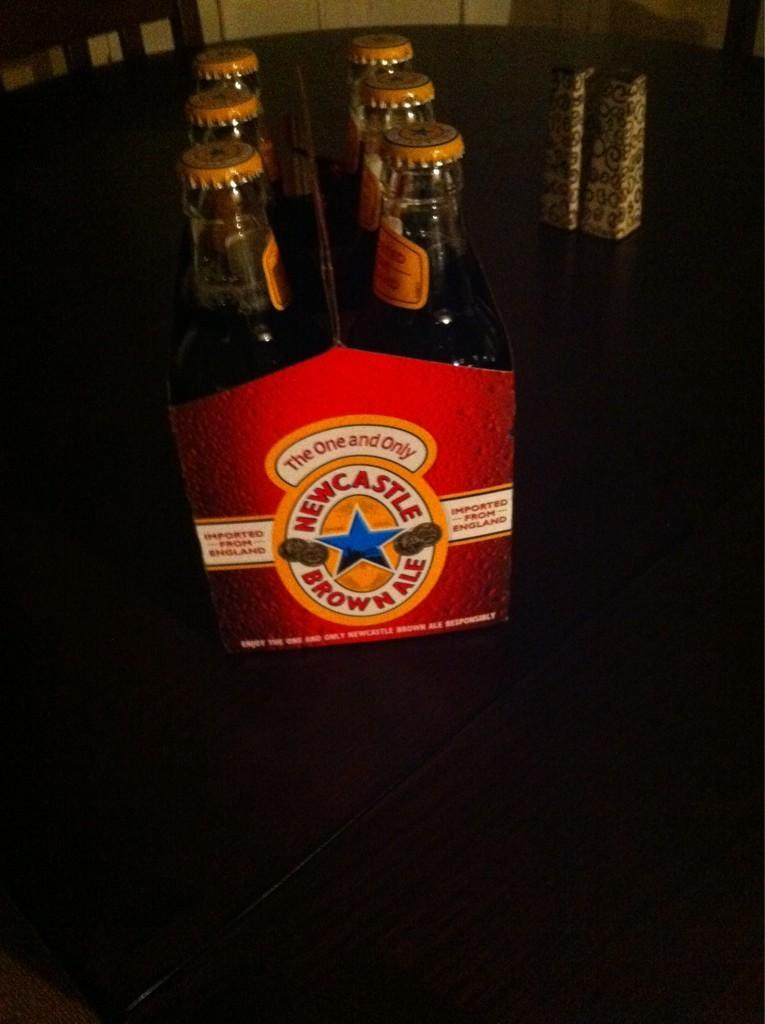Provide a one-sentence caption for the provided image. A six pack of bottled Newcastle Brown Ale. 